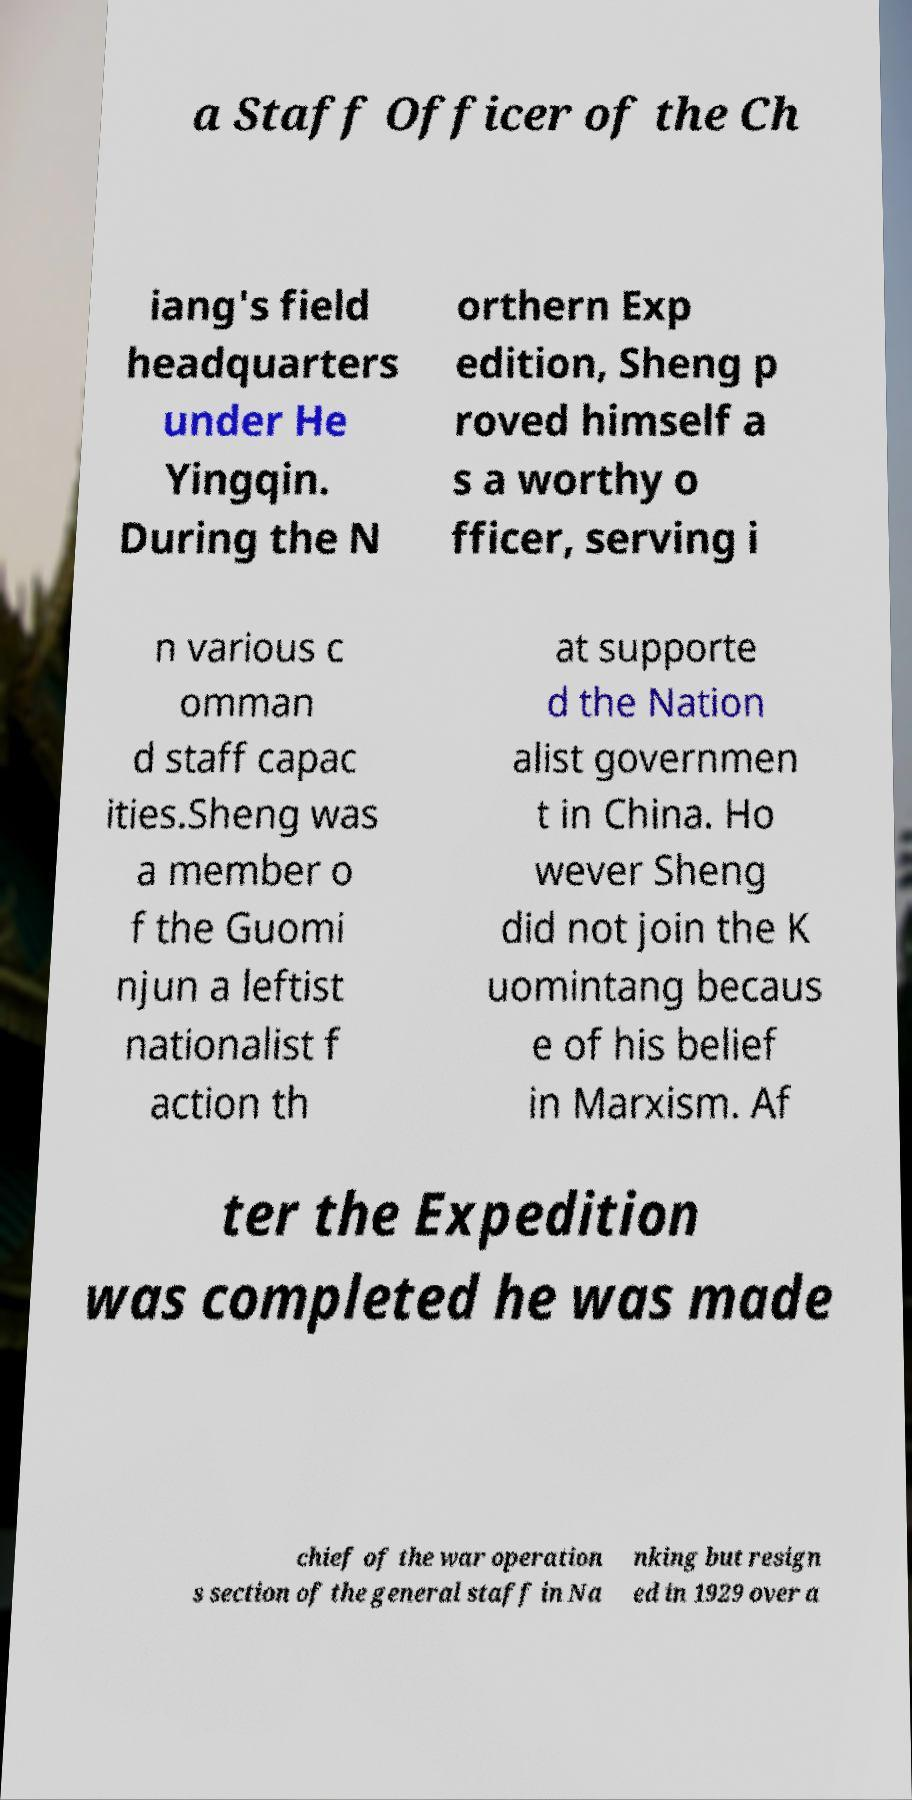Could you assist in decoding the text presented in this image and type it out clearly? a Staff Officer of the Ch iang's field headquarters under He Yingqin. During the N orthern Exp edition, Sheng p roved himself a s a worthy o fficer, serving i n various c omman d staff capac ities.Sheng was a member o f the Guomi njun a leftist nationalist f action th at supporte d the Nation alist governmen t in China. Ho wever Sheng did not join the K uomintang becaus e of his belief in Marxism. Af ter the Expedition was completed he was made chief of the war operation s section of the general staff in Na nking but resign ed in 1929 over a 